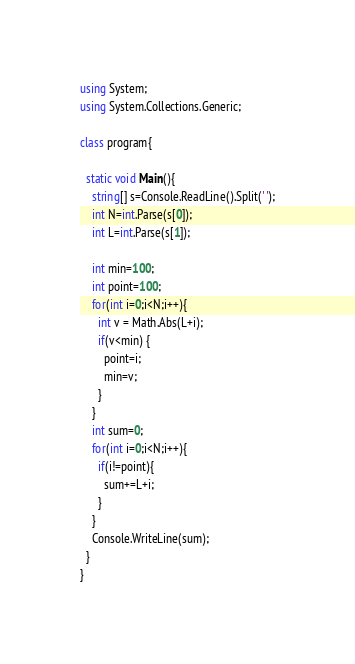<code> <loc_0><loc_0><loc_500><loc_500><_C#_>using System;
using System.Collections.Generic;

class program{

  static void Main(){
    string[] s=Console.ReadLine().Split(' ');
    int N=int.Parse(s[0]);
    int L=int.Parse(s[1]);
    
    int min=100;
    int point=100;
    for(int i=0;i<N;i++){
      int v = Math.Abs(L+i);
      if(v<min) {
        point=i;
        min=v;
      }      
    }
    int sum=0;
    for(int i=0;i<N;i++){
      if(i!=point){
        sum+=L+i;
      }
    }    
    Console.WriteLine(sum);
  }
}</code> 